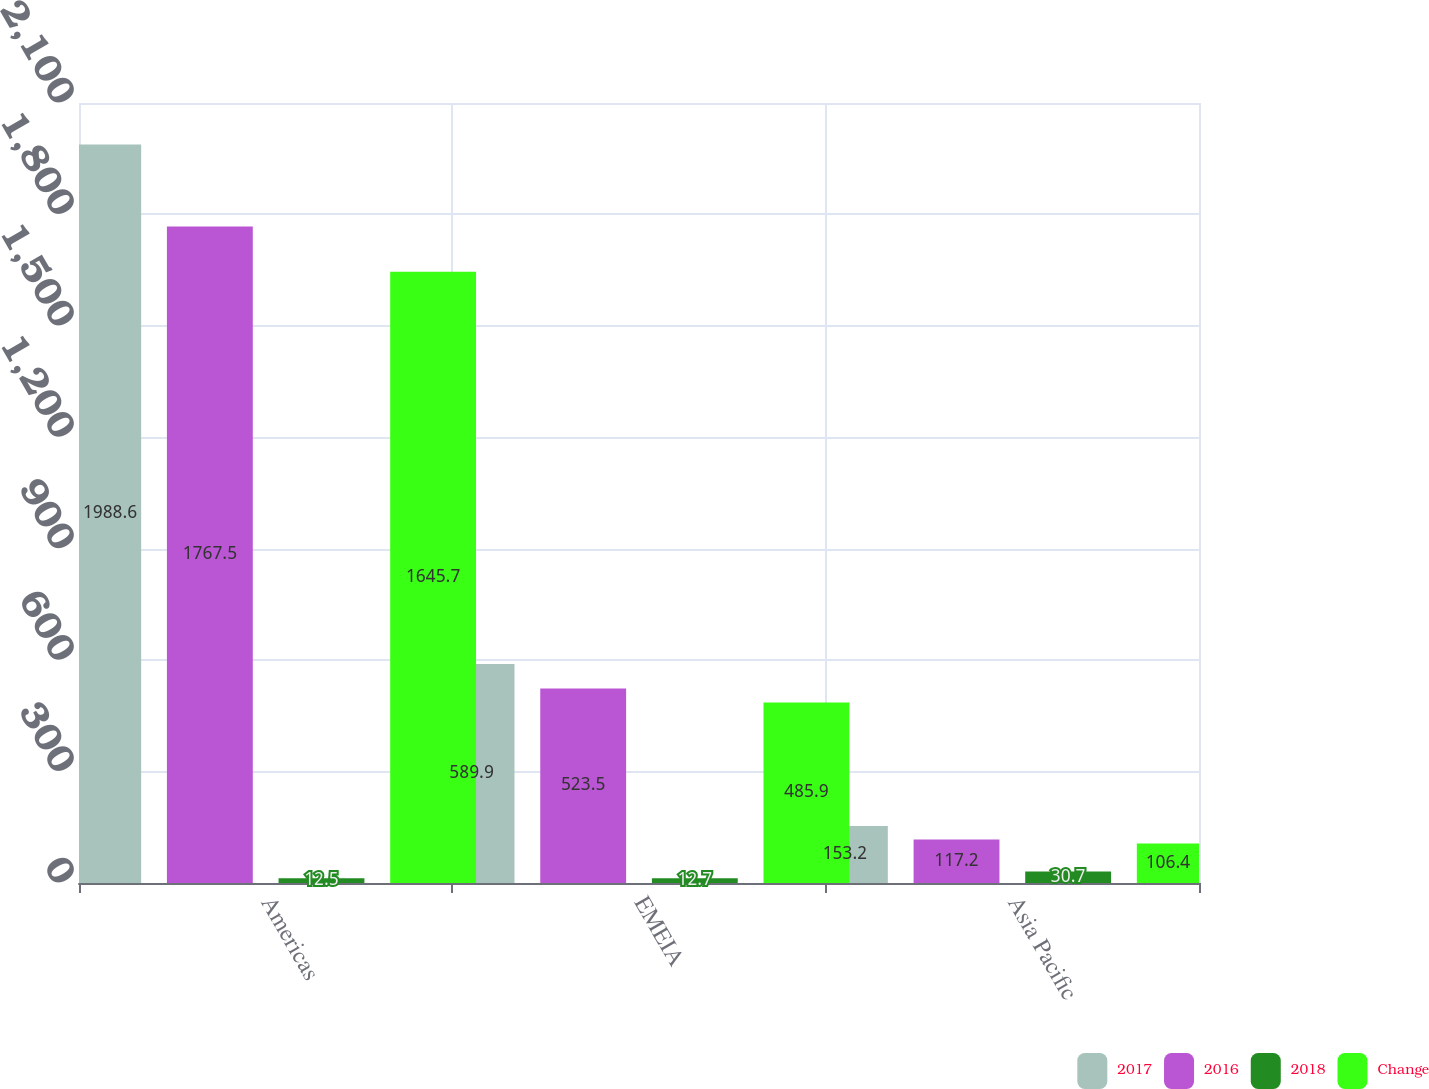Convert chart. <chart><loc_0><loc_0><loc_500><loc_500><stacked_bar_chart><ecel><fcel>Americas<fcel>EMEIA<fcel>Asia Pacific<nl><fcel>2017<fcel>1988.6<fcel>589.9<fcel>153.2<nl><fcel>2016<fcel>1767.5<fcel>523.5<fcel>117.2<nl><fcel>2018<fcel>12.5<fcel>12.7<fcel>30.7<nl><fcel>Change<fcel>1645.7<fcel>485.9<fcel>106.4<nl></chart> 